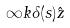<formula> <loc_0><loc_0><loc_500><loc_500>\infty k \delta ( s ) \hat { z }</formula> 